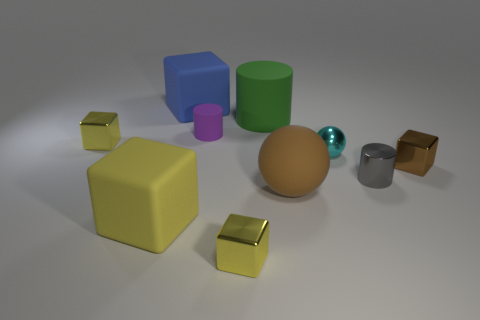How many yellow cubes must be subtracted to get 2 yellow cubes? 1 Subtract all matte cylinders. How many cylinders are left? 1 Subtract all balls. How many objects are left? 8 Add 7 tiny shiny blocks. How many tiny shiny blocks exist? 10 Subtract all blue cubes. How many cubes are left? 4 Subtract 0 cyan cylinders. How many objects are left? 10 Subtract 1 cylinders. How many cylinders are left? 2 Subtract all purple spheres. Subtract all blue blocks. How many spheres are left? 2 Subtract all cyan balls. How many brown cubes are left? 1 Subtract all large yellow matte cubes. Subtract all large blocks. How many objects are left? 7 